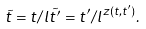<formula> <loc_0><loc_0><loc_500><loc_500>\tilde { t } = t / l \tilde { t ^ { \prime } } = t ^ { \prime } / l ^ { z ( t , t ^ { \prime } ) } .</formula> 